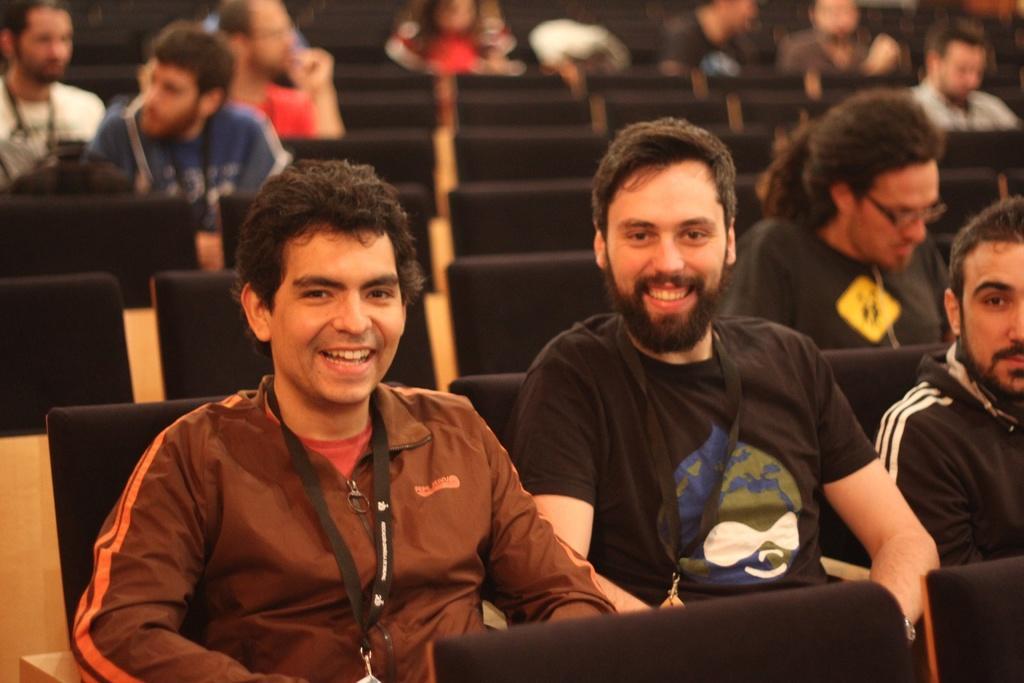How would you summarize this image in a sentence or two? Front we can see people are sitting on chairs. These two people are smiling and wire tags. Background it is blur. We can see people are sitting on black chairs. 